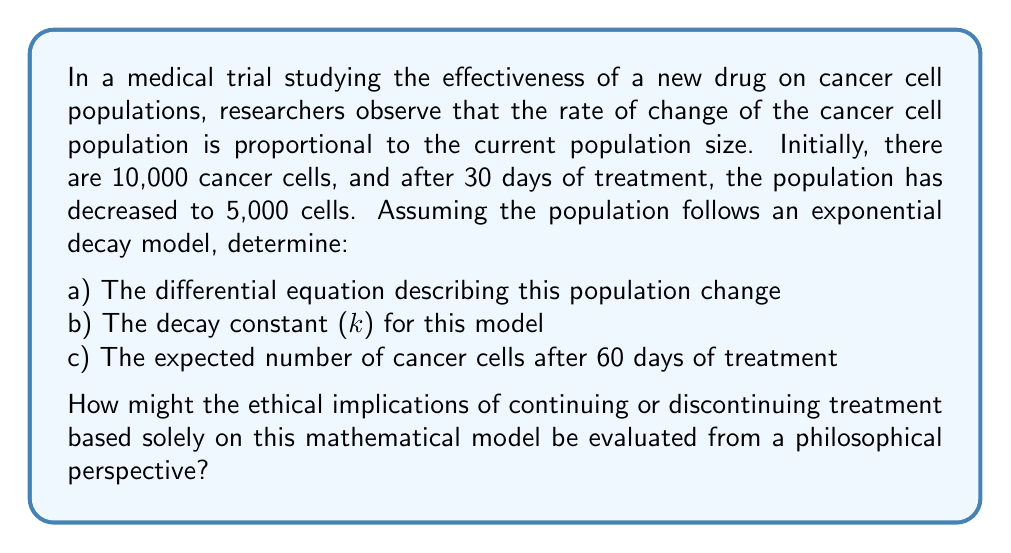Help me with this question. Let's approach this problem step-by-step:

a) The differential equation for exponential decay is:

$$\frac{dP}{dt} = -kP$$

Where $P$ is the population size, $t$ is time, and $k$ is the decay constant.

b) To find the decay constant $k$, we use the exponential decay formula:

$$P(t) = P_0e^{-kt}$$

Where $P_0$ is the initial population and $P(t)$ is the population at time $t$.

Given:
$P_0 = 10,000$
$P(30) = 5,000$
$t = 30$ days

Substituting these values:

$$5,000 = 10,000e^{-30k}$$

Simplifying:

$$\frac{1}{2} = e^{-30k}$$

Taking the natural log of both sides:

$$\ln(\frac{1}{2}) = -30k$$

$$-\ln(2) = -30k$$

Solving for $k$:

$$k = \frac{\ln(2)}{30} \approx 0.0231$$

c) To find the expected number of cancer cells after 60 days, we use the exponential decay formula with $t = 60$:

$$P(60) = 10,000e^{-0.0231 * 60} \approx 2,500$$

From a philosophical perspective, evaluating the ethical implications of continuing or discontinuing treatment based solely on this mathematical model raises several important questions:

1. Reductionism: Is it ethically sound to reduce the complexity of cancer treatment to a single mathematical model?
2. Evidential standards: What constitutes sufficient evidence for medical decision-making? Is this model alone adequate?
3. Patient autonomy: How does this model impact patient choice and informed consent?
4. Beneficence vs. non-maleficence: How do we balance potential benefits against potential harm when interpreting this model?
5. Justice and resource allocation: How might this model influence decisions about resource distribution in healthcare?

These philosophical considerations highlight the need for a nuanced approach that combines mathematical modeling with broader ethical and practical considerations in medical decision-making.
Answer: a) $\frac{dP}{dt} = -kP$
b) $k \approx 0.0231$
c) $P(60) \approx 2,500$ cancer cells 